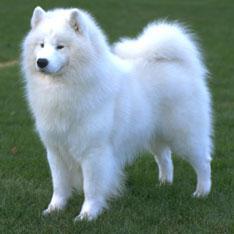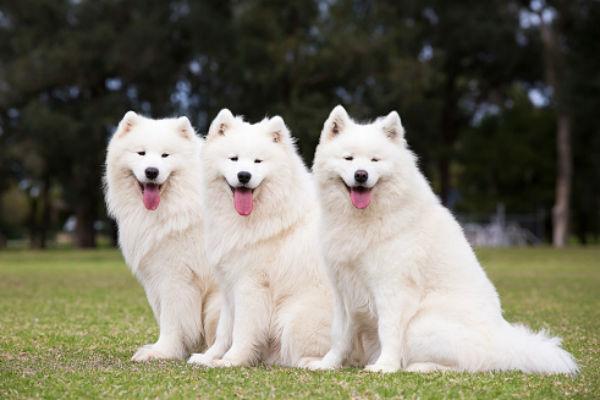The first image is the image on the left, the second image is the image on the right. Assess this claim about the two images: "Only one dog is contained in each image.". Correct or not? Answer yes or no. No. The first image is the image on the left, the second image is the image on the right. For the images shown, is this caption "Each image contains exactly one white dog, and each dog is in the same type of pose." true? Answer yes or no. No. 